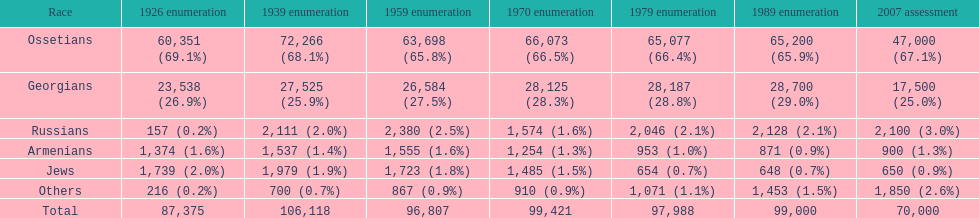What was the first census that saw a russian population of over 2,000? 1939 census. 